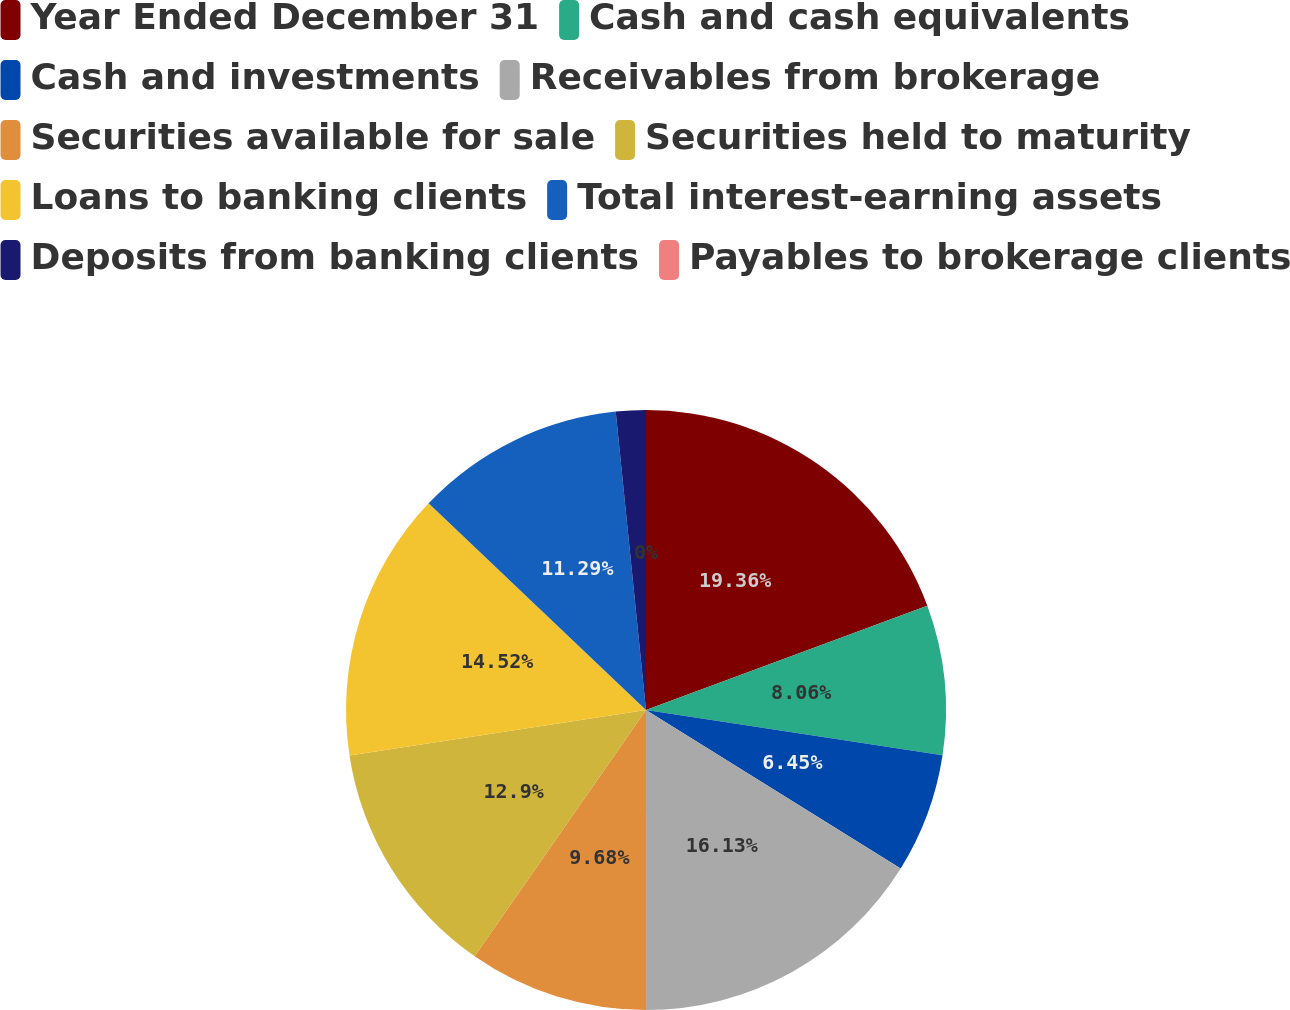<chart> <loc_0><loc_0><loc_500><loc_500><pie_chart><fcel>Year Ended December 31<fcel>Cash and cash equivalents<fcel>Cash and investments<fcel>Receivables from brokerage<fcel>Securities available for sale<fcel>Securities held to maturity<fcel>Loans to banking clients<fcel>Total interest-earning assets<fcel>Deposits from banking clients<fcel>Payables to brokerage clients<nl><fcel>19.35%<fcel>8.06%<fcel>6.45%<fcel>16.13%<fcel>9.68%<fcel>12.9%<fcel>14.52%<fcel>11.29%<fcel>1.61%<fcel>0.0%<nl></chart> 